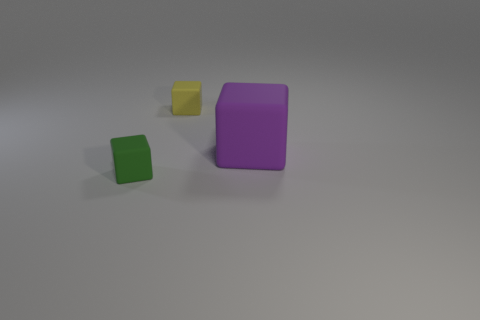What number of other things are the same color as the big object? There are no other objects that share the same color as the large purple object in the image. The smaller objects are yellow and green, distinguishing them from the larger one. 